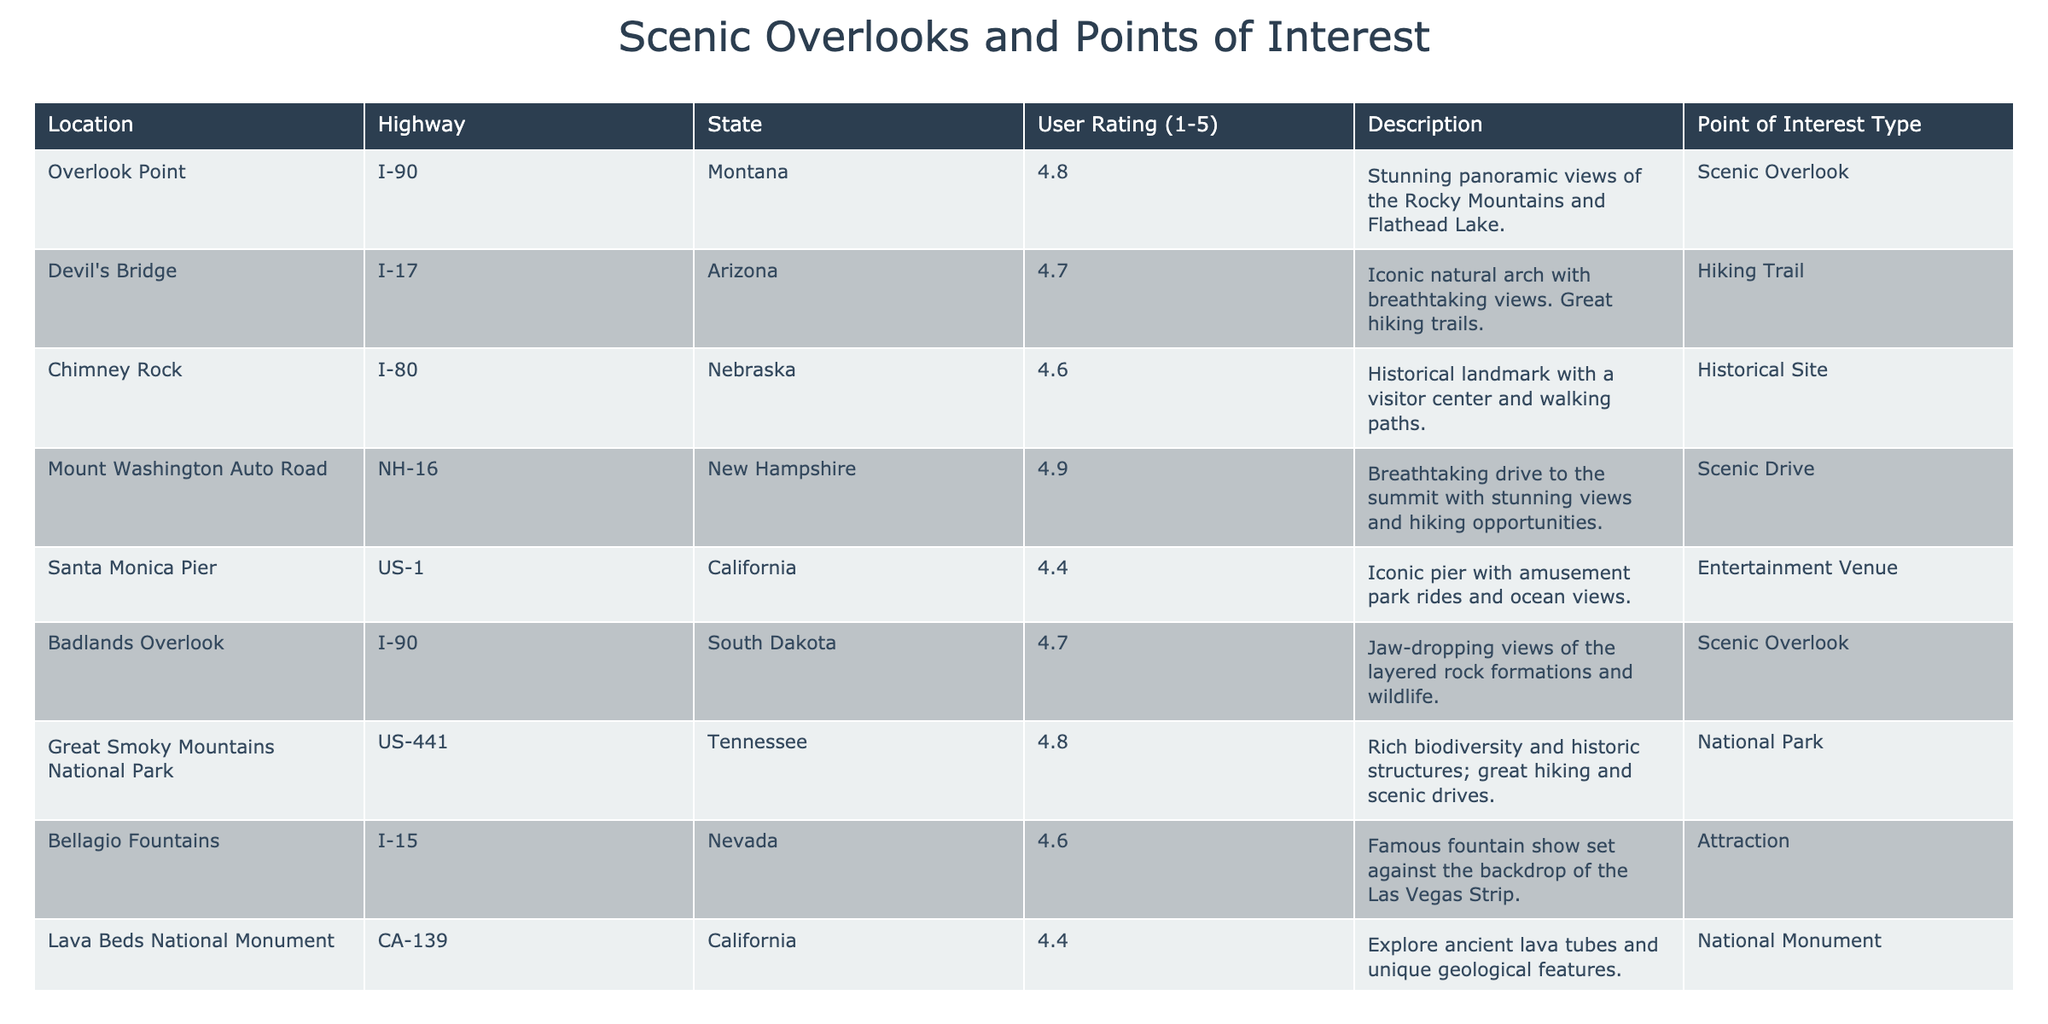What is the user rating for Devil's Bridge? The user rating for Devil's Bridge is listed in the table under the "User Rating (1-5)" column. It shows a rating of 4.7.
Answer: 4.7 Which location has the highest user rating and what is that rating? Looking through the "User Rating (1-5)" column, the highest value is 4.9, which corresponds to "Mount Washington Auto Road" and "Lake Tahoe Scenic Drive".
Answer: Mount Washington Auto Road and Lake Tahoe Scenic Drive; 4.9 Is Santa Monica Pier rated higher than Picnic Rock? Checking the user ratings for both locations: Santa Monica Pier has a rating of 4.4, while Picnic Rock has a rating of 4.3. Since 4.4 is greater than 4.3, Santa Monica Pier is indeed rated higher.
Answer: Yes What is the average user rating for the scenic overlooks? The scenic overlooks listed are "Overlook Point" (4.8) and "Badlands Overlook" (4.7). To find the average, add these ratings: 4.8 + 4.7 = 9.5, then divide by the number of overlooks, which is 2. So, the average rating is 9.5 / 2 = 4.75.
Answer: 4.75 How many points of interest have a user rating of 4.5 or higher? By examining the table, count each entry with a rating of 4.5 or higher: "Overlook Point" (4.8), "Devil's Bridge" (4.7), "Chimney Rock" (4.6), "Mount Washington Auto Road" (4.9), "Great Smoky Mountains National Park" (4.8), "Bellagio Fountains" (4.6), "Lake Tahoe Scenic Drive" (4.9). There are 7 in total.
Answer: 7 Which is the only point of interest that is classified as a "Picnic Area"? "Picnic Rock" is identified in the "Point of Interest Type" column as the only entry listed as a "Picnic Area" in the table.
Answer: Picnic Rock Which state has the scenic drive with the highest rating? The highest-rated scenic drive is "Lake Tahoe Scenic Drive" from California with a user rating of 4.9. No other drive has a higher rating, so California would be the state with the highest-rated scenic drive.
Answer: California List all points of interest with a user rating lower than 4.5. Reviewing the table for user ratings lower than 4.5, we find that "Santa Monica Pier" (4.4), "Lava Beds National Monument" (4.4), and "Picnic Rock" (4.3) meet this criterion. Therefore, those are the points of interest with lower ratings.
Answer: Santa Monica Pier, Lava Beds National Monument, Picnic Rock 